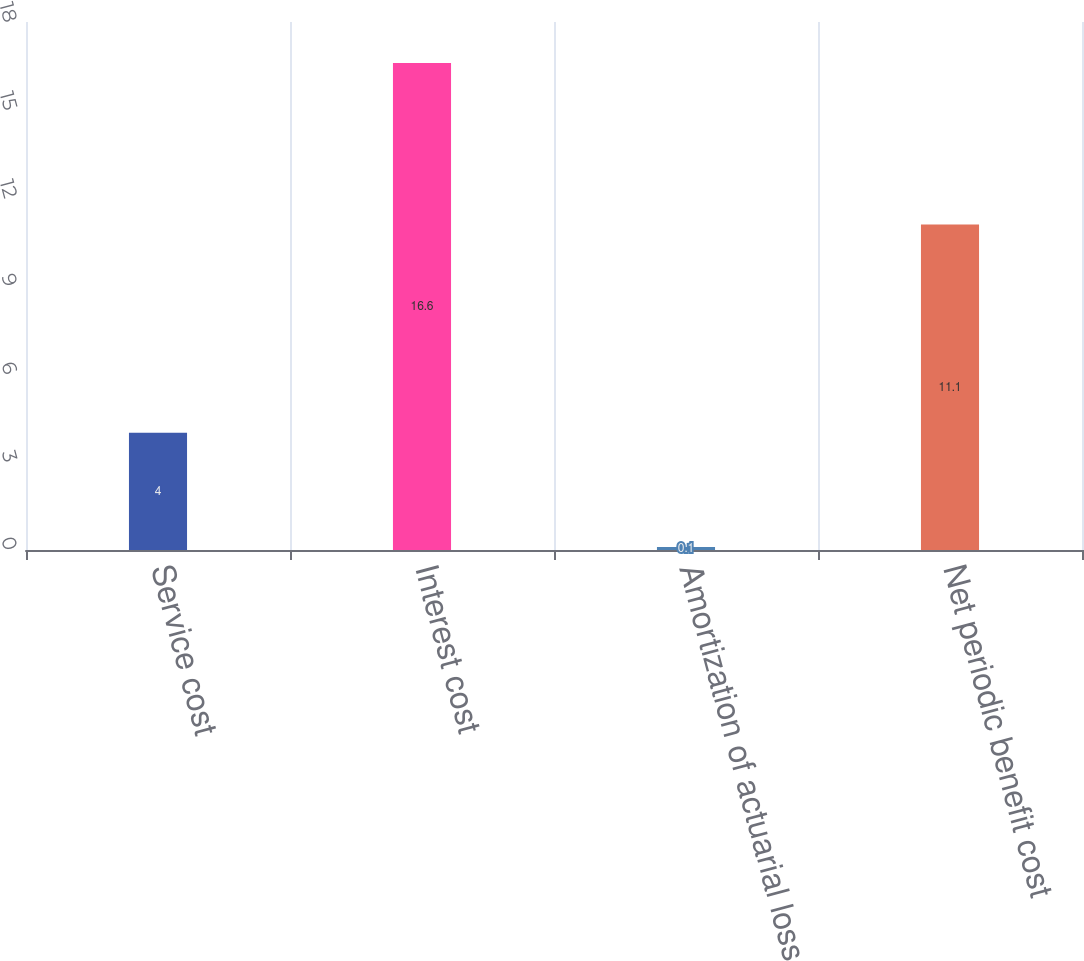Convert chart to OTSL. <chart><loc_0><loc_0><loc_500><loc_500><bar_chart><fcel>Service cost<fcel>Interest cost<fcel>Amortization of actuarial loss<fcel>Net periodic benefit cost<nl><fcel>4<fcel>16.6<fcel>0.1<fcel>11.1<nl></chart> 